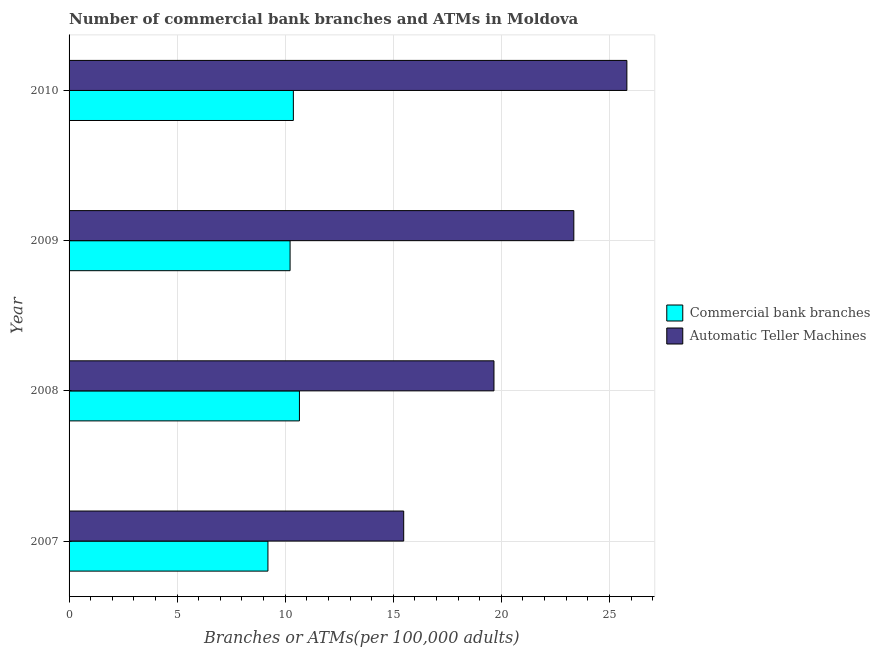Are the number of bars per tick equal to the number of legend labels?
Make the answer very short. Yes. What is the label of the 2nd group of bars from the top?
Make the answer very short. 2009. What is the number of commercal bank branches in 2008?
Provide a short and direct response. 10.66. Across all years, what is the maximum number of commercal bank branches?
Your answer should be compact. 10.66. Across all years, what is the minimum number of commercal bank branches?
Make the answer very short. 9.2. What is the total number of atms in the graph?
Your response must be concise. 84.3. What is the difference between the number of atms in 2007 and that in 2008?
Your response must be concise. -4.18. What is the difference between the number of atms in 2009 and the number of commercal bank branches in 2007?
Keep it short and to the point. 14.15. What is the average number of atms per year?
Provide a short and direct response. 21.07. In the year 2007, what is the difference between the number of commercal bank branches and number of atms?
Make the answer very short. -6.28. In how many years, is the number of commercal bank branches greater than 7 ?
Your response must be concise. 4. What is the ratio of the number of atms in 2008 to that in 2009?
Keep it short and to the point. 0.84. Is the difference between the number of commercal bank branches in 2008 and 2009 greater than the difference between the number of atms in 2008 and 2009?
Your answer should be very brief. Yes. What is the difference between the highest and the second highest number of commercal bank branches?
Give a very brief answer. 0.28. What is the difference between the highest and the lowest number of atms?
Offer a very short reply. 10.32. In how many years, is the number of atms greater than the average number of atms taken over all years?
Provide a short and direct response. 2. What does the 2nd bar from the top in 2009 represents?
Offer a very short reply. Commercial bank branches. What does the 1st bar from the bottom in 2010 represents?
Make the answer very short. Commercial bank branches. How many bars are there?
Your answer should be very brief. 8. Are the values on the major ticks of X-axis written in scientific E-notation?
Make the answer very short. No. Does the graph contain any zero values?
Your response must be concise. No. Where does the legend appear in the graph?
Ensure brevity in your answer.  Center right. What is the title of the graph?
Give a very brief answer. Number of commercial bank branches and ATMs in Moldova. What is the label or title of the X-axis?
Your answer should be very brief. Branches or ATMs(per 100,0 adults). What is the label or title of the Y-axis?
Your response must be concise. Year. What is the Branches or ATMs(per 100,000 adults) of Commercial bank branches in 2007?
Make the answer very short. 9.2. What is the Branches or ATMs(per 100,000 adults) in Automatic Teller Machines in 2007?
Offer a very short reply. 15.48. What is the Branches or ATMs(per 100,000 adults) in Commercial bank branches in 2008?
Offer a very short reply. 10.66. What is the Branches or ATMs(per 100,000 adults) in Automatic Teller Machines in 2008?
Your response must be concise. 19.66. What is the Branches or ATMs(per 100,000 adults) of Commercial bank branches in 2009?
Make the answer very short. 10.23. What is the Branches or ATMs(per 100,000 adults) in Automatic Teller Machines in 2009?
Keep it short and to the point. 23.35. What is the Branches or ATMs(per 100,000 adults) of Commercial bank branches in 2010?
Give a very brief answer. 10.38. What is the Branches or ATMs(per 100,000 adults) of Automatic Teller Machines in 2010?
Ensure brevity in your answer.  25.81. Across all years, what is the maximum Branches or ATMs(per 100,000 adults) in Commercial bank branches?
Give a very brief answer. 10.66. Across all years, what is the maximum Branches or ATMs(per 100,000 adults) of Automatic Teller Machines?
Ensure brevity in your answer.  25.81. Across all years, what is the minimum Branches or ATMs(per 100,000 adults) of Commercial bank branches?
Keep it short and to the point. 9.2. Across all years, what is the minimum Branches or ATMs(per 100,000 adults) of Automatic Teller Machines?
Provide a succinct answer. 15.48. What is the total Branches or ATMs(per 100,000 adults) in Commercial bank branches in the graph?
Give a very brief answer. 40.46. What is the total Branches or ATMs(per 100,000 adults) of Automatic Teller Machines in the graph?
Ensure brevity in your answer.  84.3. What is the difference between the Branches or ATMs(per 100,000 adults) in Commercial bank branches in 2007 and that in 2008?
Your answer should be compact. -1.46. What is the difference between the Branches or ATMs(per 100,000 adults) in Automatic Teller Machines in 2007 and that in 2008?
Offer a very short reply. -4.18. What is the difference between the Branches or ATMs(per 100,000 adults) in Commercial bank branches in 2007 and that in 2009?
Ensure brevity in your answer.  -1.02. What is the difference between the Branches or ATMs(per 100,000 adults) in Automatic Teller Machines in 2007 and that in 2009?
Your answer should be compact. -7.87. What is the difference between the Branches or ATMs(per 100,000 adults) in Commercial bank branches in 2007 and that in 2010?
Offer a terse response. -1.18. What is the difference between the Branches or ATMs(per 100,000 adults) in Automatic Teller Machines in 2007 and that in 2010?
Provide a succinct answer. -10.32. What is the difference between the Branches or ATMs(per 100,000 adults) of Commercial bank branches in 2008 and that in 2009?
Make the answer very short. 0.43. What is the difference between the Branches or ATMs(per 100,000 adults) of Automatic Teller Machines in 2008 and that in 2009?
Ensure brevity in your answer.  -3.69. What is the difference between the Branches or ATMs(per 100,000 adults) of Commercial bank branches in 2008 and that in 2010?
Offer a terse response. 0.28. What is the difference between the Branches or ATMs(per 100,000 adults) in Automatic Teller Machines in 2008 and that in 2010?
Your answer should be very brief. -6.15. What is the difference between the Branches or ATMs(per 100,000 adults) of Commercial bank branches in 2009 and that in 2010?
Provide a short and direct response. -0.15. What is the difference between the Branches or ATMs(per 100,000 adults) of Automatic Teller Machines in 2009 and that in 2010?
Offer a very short reply. -2.45. What is the difference between the Branches or ATMs(per 100,000 adults) in Commercial bank branches in 2007 and the Branches or ATMs(per 100,000 adults) in Automatic Teller Machines in 2008?
Offer a very short reply. -10.46. What is the difference between the Branches or ATMs(per 100,000 adults) of Commercial bank branches in 2007 and the Branches or ATMs(per 100,000 adults) of Automatic Teller Machines in 2009?
Offer a very short reply. -14.15. What is the difference between the Branches or ATMs(per 100,000 adults) in Commercial bank branches in 2007 and the Branches or ATMs(per 100,000 adults) in Automatic Teller Machines in 2010?
Keep it short and to the point. -16.61. What is the difference between the Branches or ATMs(per 100,000 adults) of Commercial bank branches in 2008 and the Branches or ATMs(per 100,000 adults) of Automatic Teller Machines in 2009?
Make the answer very short. -12.69. What is the difference between the Branches or ATMs(per 100,000 adults) in Commercial bank branches in 2008 and the Branches or ATMs(per 100,000 adults) in Automatic Teller Machines in 2010?
Give a very brief answer. -15.15. What is the difference between the Branches or ATMs(per 100,000 adults) in Commercial bank branches in 2009 and the Branches or ATMs(per 100,000 adults) in Automatic Teller Machines in 2010?
Your answer should be very brief. -15.58. What is the average Branches or ATMs(per 100,000 adults) of Commercial bank branches per year?
Your answer should be very brief. 10.12. What is the average Branches or ATMs(per 100,000 adults) in Automatic Teller Machines per year?
Offer a very short reply. 21.07. In the year 2007, what is the difference between the Branches or ATMs(per 100,000 adults) in Commercial bank branches and Branches or ATMs(per 100,000 adults) in Automatic Teller Machines?
Offer a very short reply. -6.28. In the year 2008, what is the difference between the Branches or ATMs(per 100,000 adults) of Commercial bank branches and Branches or ATMs(per 100,000 adults) of Automatic Teller Machines?
Provide a short and direct response. -9. In the year 2009, what is the difference between the Branches or ATMs(per 100,000 adults) in Commercial bank branches and Branches or ATMs(per 100,000 adults) in Automatic Teller Machines?
Give a very brief answer. -13.13. In the year 2010, what is the difference between the Branches or ATMs(per 100,000 adults) in Commercial bank branches and Branches or ATMs(per 100,000 adults) in Automatic Teller Machines?
Your answer should be compact. -15.43. What is the ratio of the Branches or ATMs(per 100,000 adults) in Commercial bank branches in 2007 to that in 2008?
Keep it short and to the point. 0.86. What is the ratio of the Branches or ATMs(per 100,000 adults) in Automatic Teller Machines in 2007 to that in 2008?
Provide a short and direct response. 0.79. What is the ratio of the Branches or ATMs(per 100,000 adults) in Commercial bank branches in 2007 to that in 2009?
Your answer should be very brief. 0.9. What is the ratio of the Branches or ATMs(per 100,000 adults) in Automatic Teller Machines in 2007 to that in 2009?
Provide a short and direct response. 0.66. What is the ratio of the Branches or ATMs(per 100,000 adults) in Commercial bank branches in 2007 to that in 2010?
Provide a succinct answer. 0.89. What is the ratio of the Branches or ATMs(per 100,000 adults) in Automatic Teller Machines in 2007 to that in 2010?
Provide a short and direct response. 0.6. What is the ratio of the Branches or ATMs(per 100,000 adults) of Commercial bank branches in 2008 to that in 2009?
Offer a very short reply. 1.04. What is the ratio of the Branches or ATMs(per 100,000 adults) in Automatic Teller Machines in 2008 to that in 2009?
Your answer should be very brief. 0.84. What is the ratio of the Branches or ATMs(per 100,000 adults) in Commercial bank branches in 2008 to that in 2010?
Your response must be concise. 1.03. What is the ratio of the Branches or ATMs(per 100,000 adults) of Automatic Teller Machines in 2008 to that in 2010?
Ensure brevity in your answer.  0.76. What is the ratio of the Branches or ATMs(per 100,000 adults) in Commercial bank branches in 2009 to that in 2010?
Provide a short and direct response. 0.99. What is the ratio of the Branches or ATMs(per 100,000 adults) in Automatic Teller Machines in 2009 to that in 2010?
Offer a terse response. 0.9. What is the difference between the highest and the second highest Branches or ATMs(per 100,000 adults) of Commercial bank branches?
Make the answer very short. 0.28. What is the difference between the highest and the second highest Branches or ATMs(per 100,000 adults) of Automatic Teller Machines?
Ensure brevity in your answer.  2.45. What is the difference between the highest and the lowest Branches or ATMs(per 100,000 adults) in Commercial bank branches?
Give a very brief answer. 1.46. What is the difference between the highest and the lowest Branches or ATMs(per 100,000 adults) of Automatic Teller Machines?
Provide a succinct answer. 10.32. 